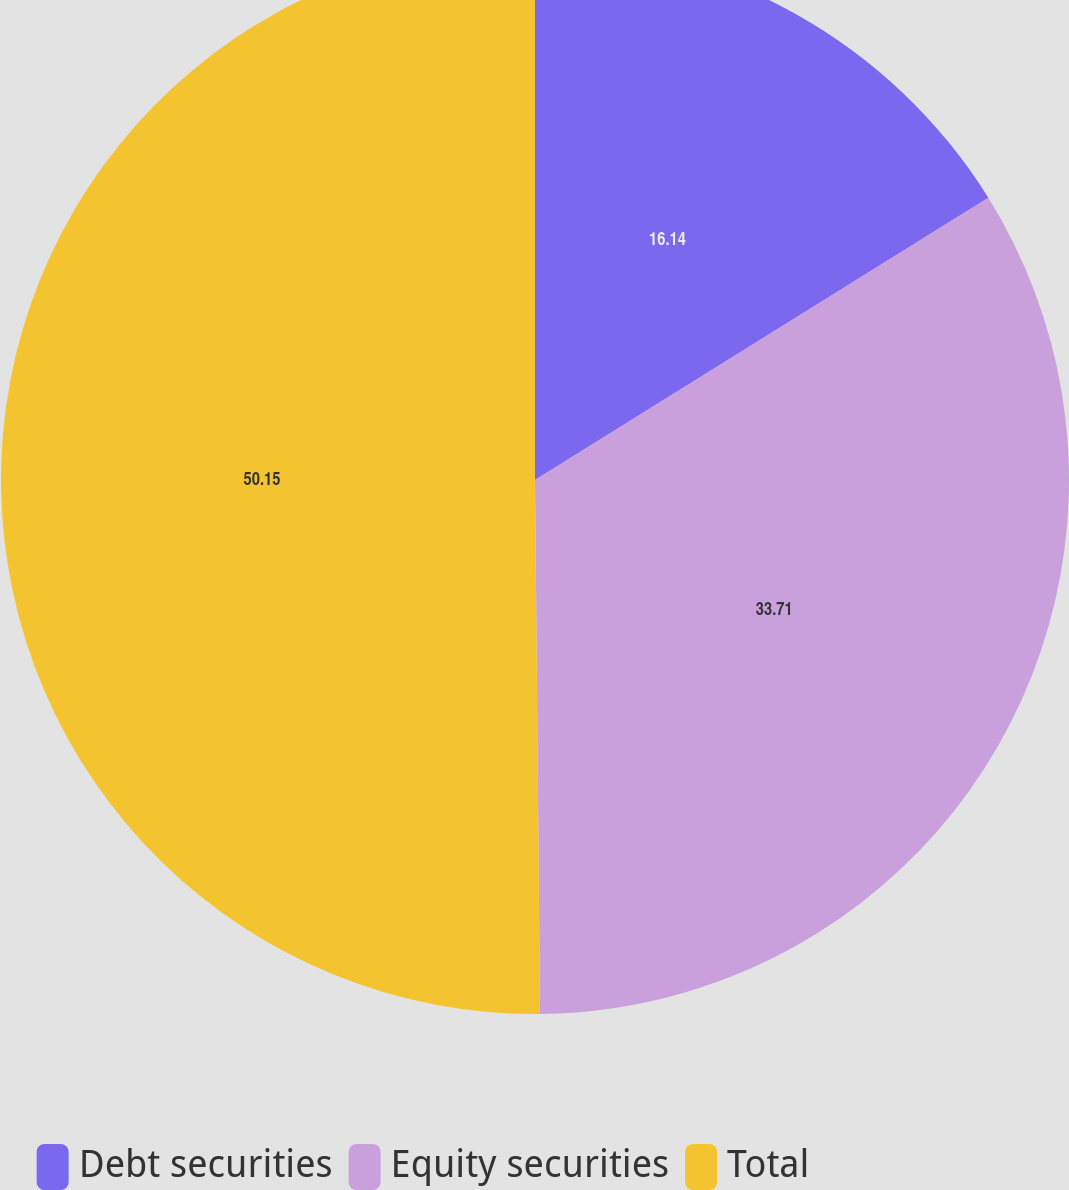Convert chart to OTSL. <chart><loc_0><loc_0><loc_500><loc_500><pie_chart><fcel>Debt securities<fcel>Equity securities<fcel>Total<nl><fcel>16.14%<fcel>33.71%<fcel>50.15%<nl></chart> 